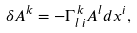<formula> <loc_0><loc_0><loc_500><loc_500>\delta A ^ { k } = - \Gamma ^ { \, k } _ { l \, i } A ^ { l } d x ^ { i } ,</formula> 